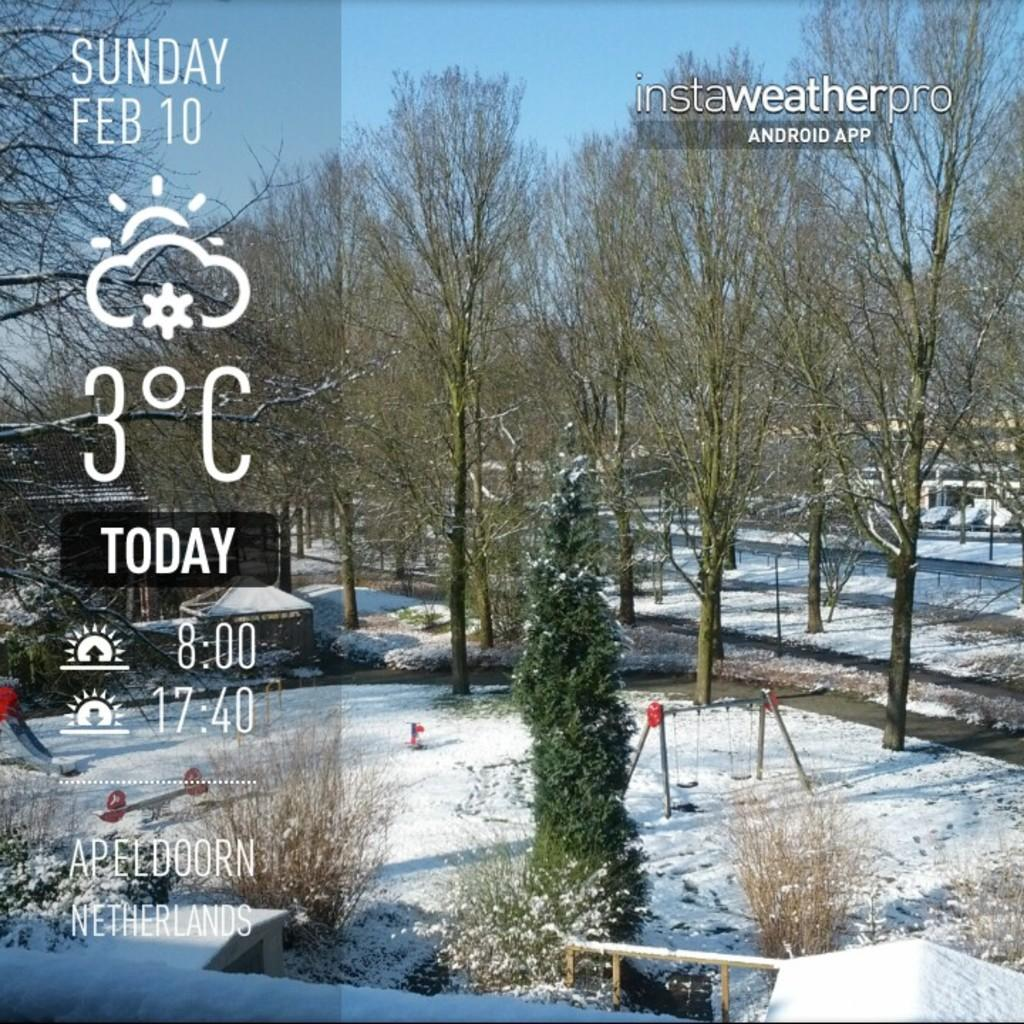What type of vegetation can be seen in the image? There are trees and plants in the image. What else is present in the image besides vegetation? There are poles in the image. What is the ground covered with at the bottom of the image? A: There is snow at the bottom of the image. Can you read any text in the image? Yes, there is some text written on the left side of the image. What type of produce is being harvested in the image? There is no produce being harvested in the image; it features trees, plants, poles, snow, and text. Who is the minister in the image? There is no minister present in the image. 